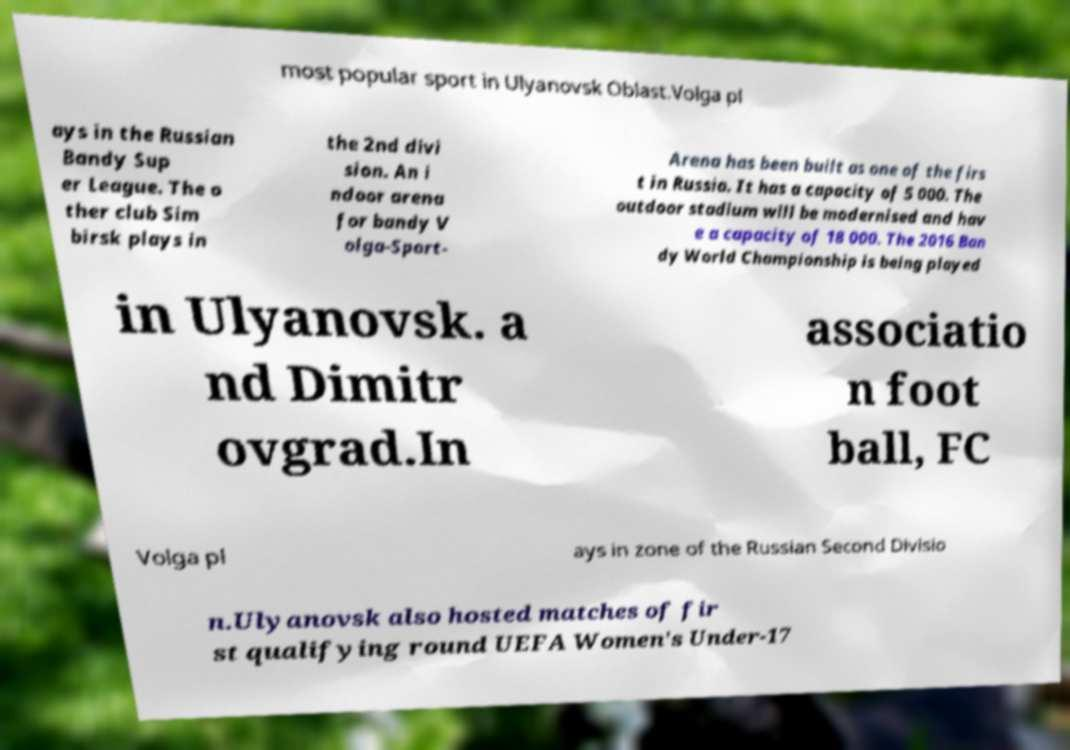What messages or text are displayed in this image? I need them in a readable, typed format. most popular sport in Ulyanovsk Oblast.Volga pl ays in the Russian Bandy Sup er League. The o ther club Sim birsk plays in the 2nd divi sion. An i ndoor arena for bandy V olga-Sport- Arena has been built as one of the firs t in Russia. It has a capacity of 5 000. The outdoor stadium will be modernised and hav e a capacity of 18 000. The 2016 Ban dy World Championship is being played in Ulyanovsk. a nd Dimitr ovgrad.In associatio n foot ball, FC Volga pl ays in zone of the Russian Second Divisio n.Ulyanovsk also hosted matches of fir st qualifying round UEFA Women's Under-17 